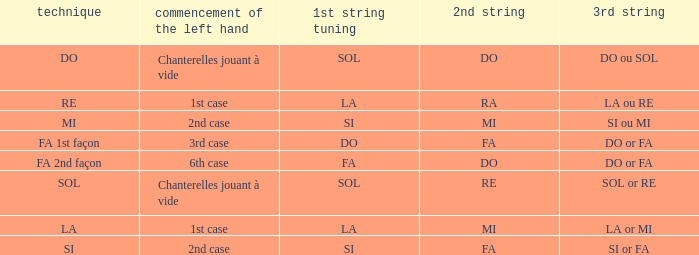For the 2nd string of do and an accord du 1st string of fa, what is the beginning of the left hand? 6th case. 